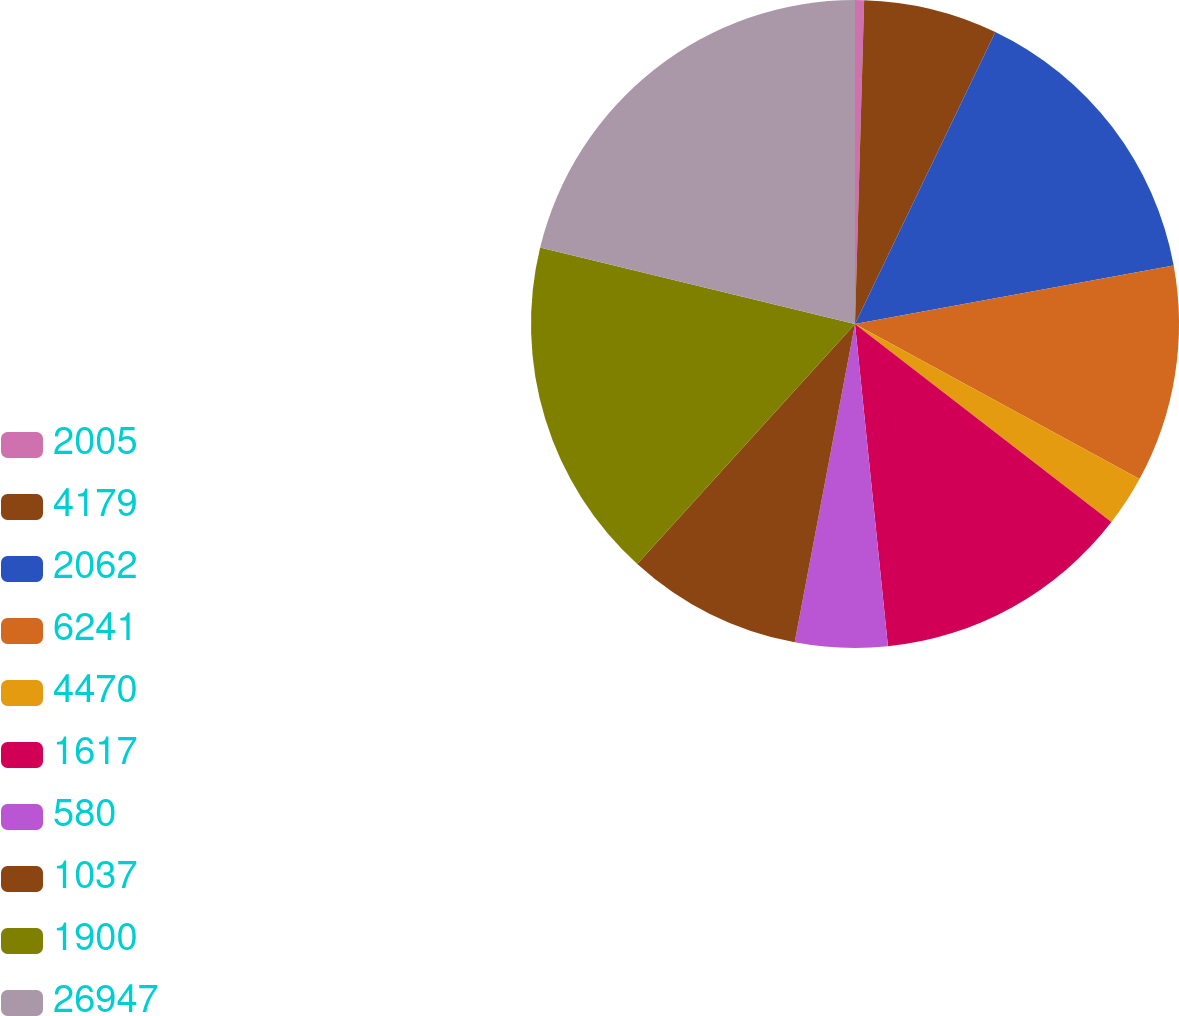Convert chart to OTSL. <chart><loc_0><loc_0><loc_500><loc_500><pie_chart><fcel>2005<fcel>4179<fcel>2062<fcel>6241<fcel>4470<fcel>1617<fcel>580<fcel>1037<fcel>1900<fcel>26947<nl><fcel>0.45%<fcel>6.68%<fcel>14.98%<fcel>10.83%<fcel>2.53%<fcel>12.91%<fcel>4.6%<fcel>8.75%<fcel>17.06%<fcel>21.21%<nl></chart> 